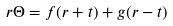Convert formula to latex. <formula><loc_0><loc_0><loc_500><loc_500>r \Theta = f ( r + t ) + g ( r - t )</formula> 